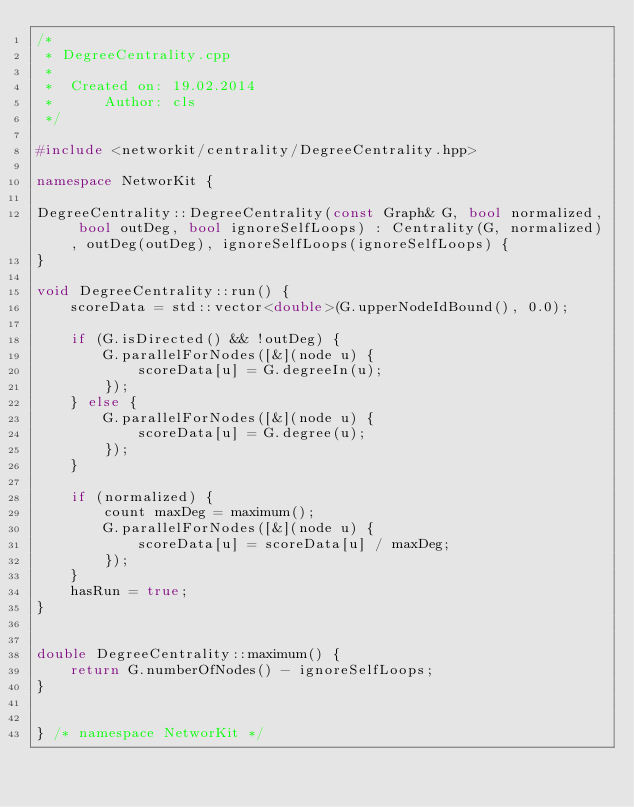<code> <loc_0><loc_0><loc_500><loc_500><_C++_>/*
 * DegreeCentrality.cpp
 *
 *  Created on: 19.02.2014
 *      Author: cls
 */

#include <networkit/centrality/DegreeCentrality.hpp>

namespace NetworKit {

DegreeCentrality::DegreeCentrality(const Graph& G, bool normalized, bool outDeg, bool ignoreSelfLoops) : Centrality(G, normalized), outDeg(outDeg), ignoreSelfLoops(ignoreSelfLoops) {
}

void DegreeCentrality::run() {
	scoreData = std::vector<double>(G.upperNodeIdBound(), 0.0);

	if (G.isDirected() && !outDeg) {
		G.parallelForNodes([&](node u) {
			scoreData[u] = G.degreeIn(u);
		});
	} else {
		G.parallelForNodes([&](node u) {
			scoreData[u] = G.degree(u);
		});
	}

	if (normalized) {
		count maxDeg = maximum();
		G.parallelForNodes([&](node u) {
			scoreData[u] = scoreData[u] / maxDeg;
		});
	}
	hasRun = true;
}


double DegreeCentrality::maximum() {
	return G.numberOfNodes() - ignoreSelfLoops;
}


} /* namespace NetworKit */
</code> 